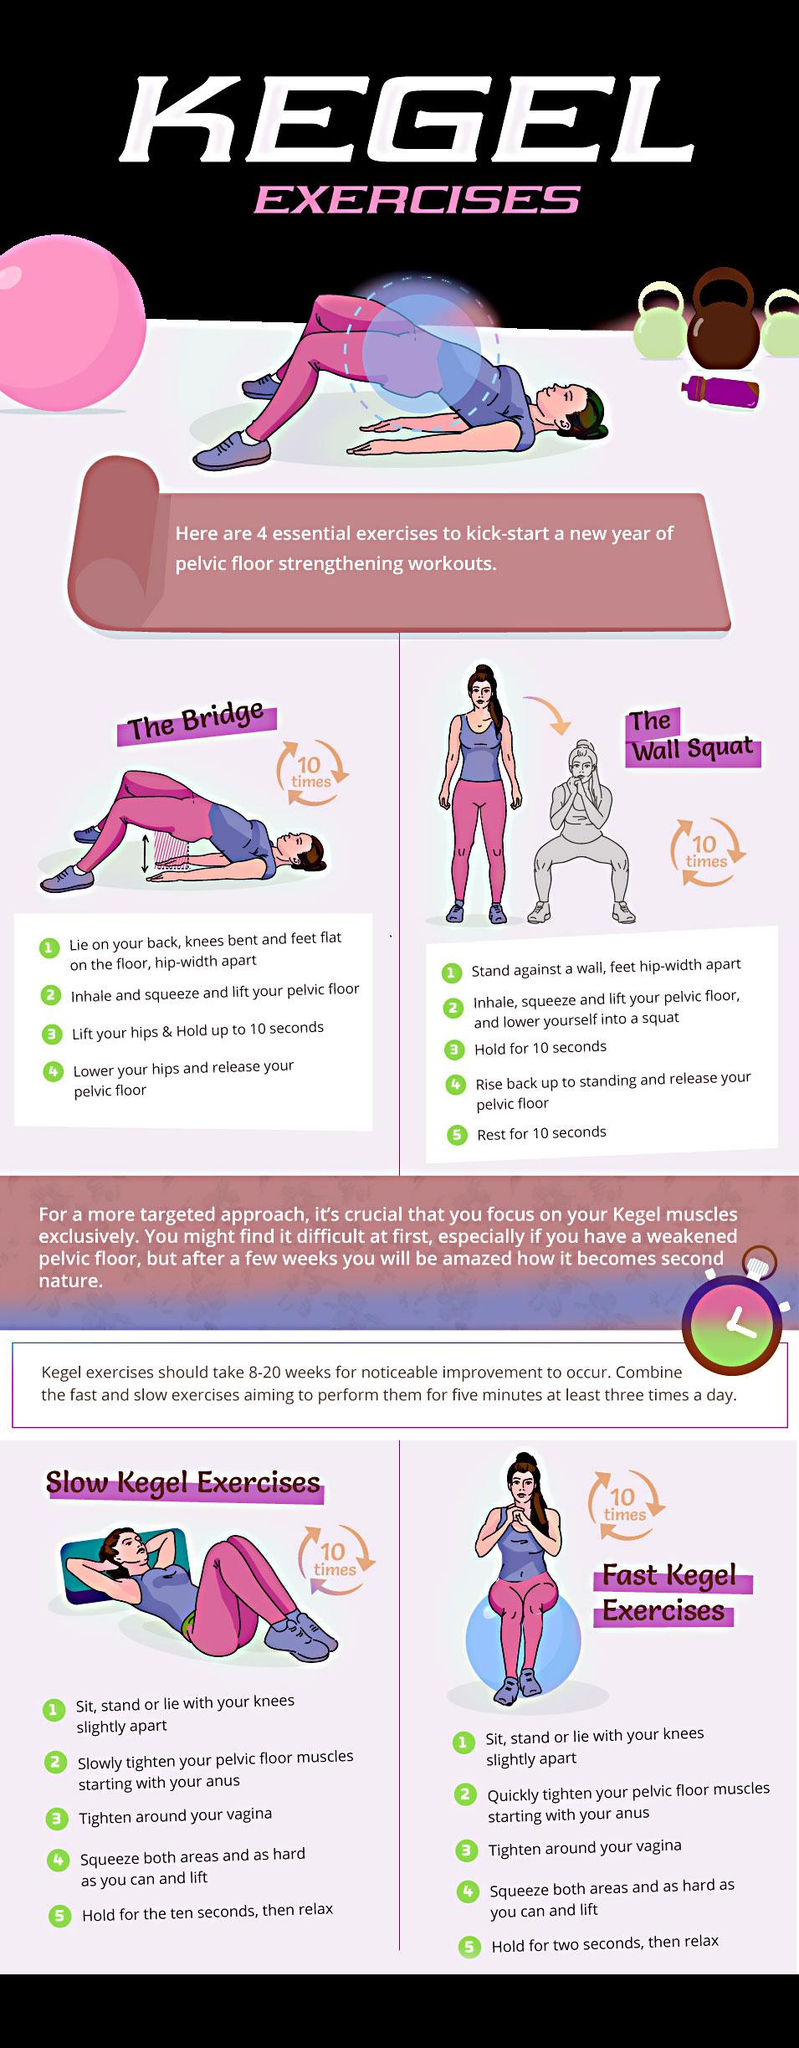Indicate a few pertinent items in this graphic. The Kegel exercises that have a hold time of 10 seconds are 3, 4, 5, 6, 7, 8, 9, and 10. The exercises should be repeated 10 times each, according to the instructions. After completing the second step in a wall squat, the next step is to hold the position for 10 seconds. 